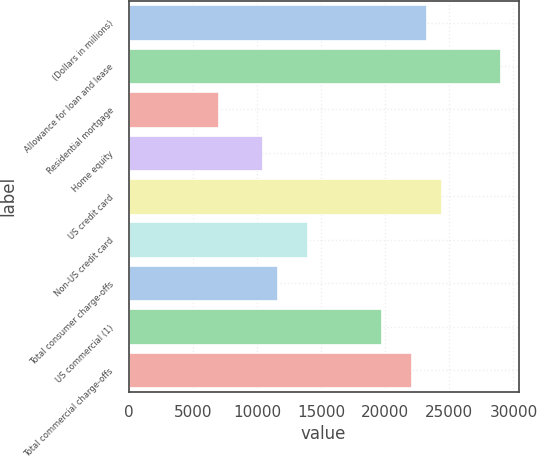<chart> <loc_0><loc_0><loc_500><loc_500><bar_chart><fcel>(Dollars in millions)<fcel>Allowance for loan and lease<fcel>Residential mortgage<fcel>Home equity<fcel>US credit card<fcel>Non-US credit card<fcel>Total consumer charge-offs<fcel>US commercial (1)<fcel>Total commercial charge-offs<nl><fcel>23169<fcel>28959.5<fcel>6955.6<fcel>10429.9<fcel>24327.1<fcel>13904.2<fcel>11588<fcel>19694.7<fcel>22010.9<nl></chart> 